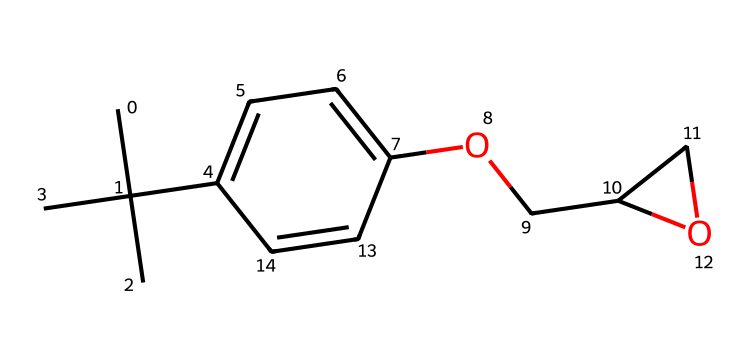What is the primary functional group present in this chemical? The given SMILES includes "OCC2CO2", indicating the presence of an ether functional group (R-O-R) due to the ether bond between oxygen and carbon.
Answer: ether How many carbon atoms are there in this molecule? Counting from the SMILES notation, we see there are 14 carbon atoms (CC(C)(C) and the other parts of the structure).
Answer: 14 Is this chemical a polar or nonpolar compound? The presence of hydroxyl (-OH) groups and the overall structure suggests that it has polar characteristics; thus, it is polar.
Answer: polar What kind of polymerization process is most likely used for this photoresist? Considering the structure and its application in wind turbine blade production, the photoresist is likely to undergo crosslinking polymerization, which is common for creating robust photoresist layers.
Answer: crosslinking What kind of application would this negative photoresist be particularly suited for? This photoresist is tailored for high-resolution patterns needed in the manufacturing of complex components like wind turbine blades, making it ideal for photolithography in industrial applications.
Answer: photolithography Does this molecule contain any ring structures? Looking at the "C2CO2" part in the SMILES, this indicates the presence of a cyclic structure involving the carbon and oxygen atoms, confirming that there is indeed a ring present.
Answer: yes 